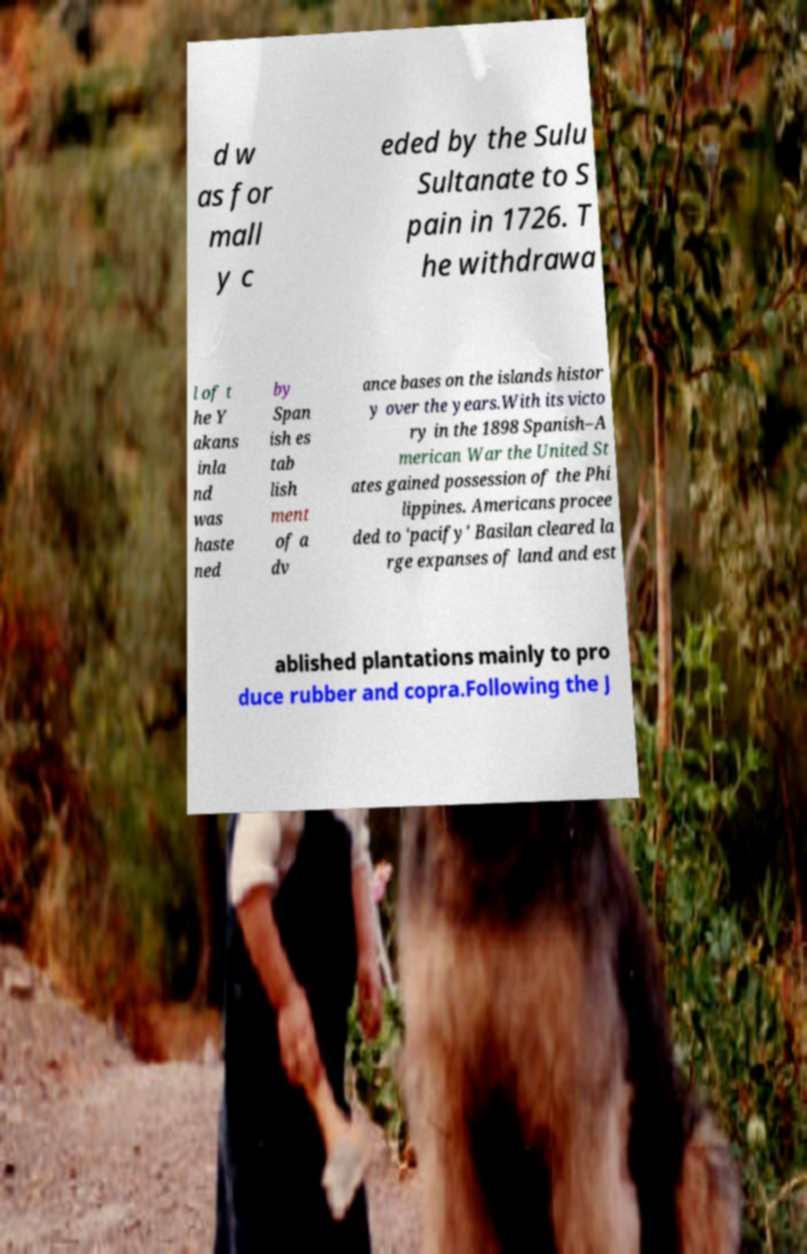Can you accurately transcribe the text from the provided image for me? d w as for mall y c eded by the Sulu Sultanate to S pain in 1726. T he withdrawa l of t he Y akans inla nd was haste ned by Span ish es tab lish ment of a dv ance bases on the islands histor y over the years.With its victo ry in the 1898 Spanish–A merican War the United St ates gained possession of the Phi lippines. Americans procee ded to 'pacify' Basilan cleared la rge expanses of land and est ablished plantations mainly to pro duce rubber and copra.Following the J 